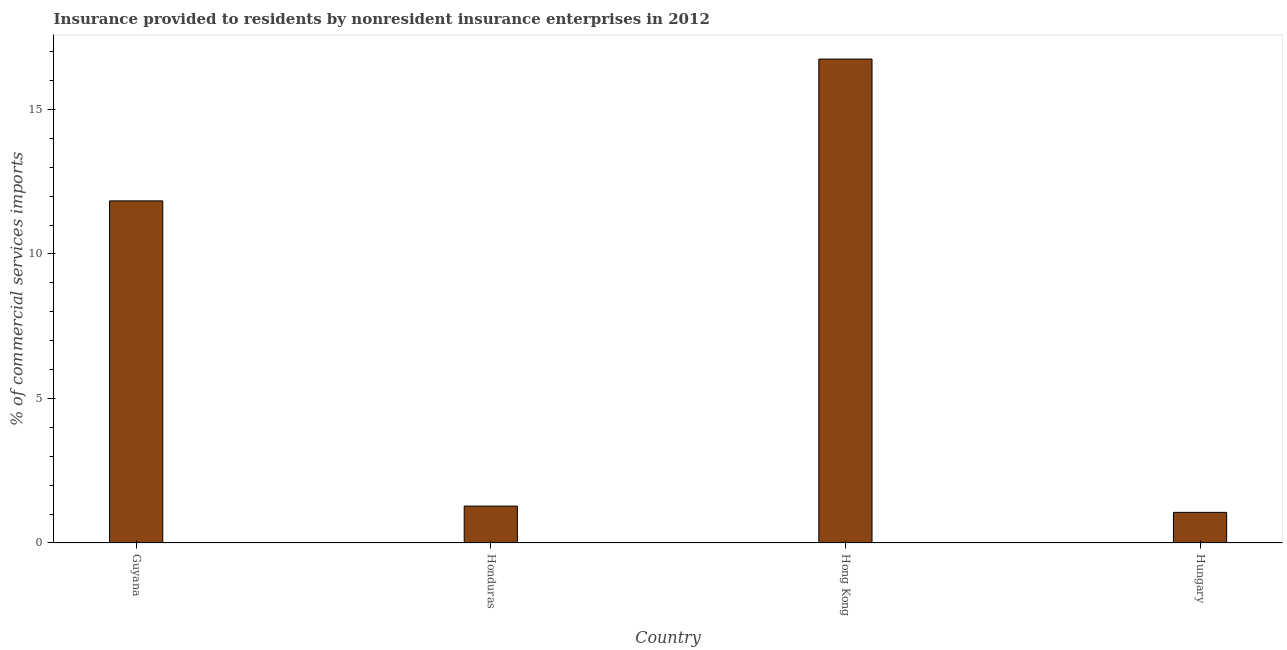Does the graph contain grids?
Keep it short and to the point. No. What is the title of the graph?
Give a very brief answer. Insurance provided to residents by nonresident insurance enterprises in 2012. What is the label or title of the Y-axis?
Keep it short and to the point. % of commercial services imports. What is the insurance provided by non-residents in Hungary?
Make the answer very short. 1.06. Across all countries, what is the maximum insurance provided by non-residents?
Your answer should be compact. 16.74. Across all countries, what is the minimum insurance provided by non-residents?
Your answer should be compact. 1.06. In which country was the insurance provided by non-residents maximum?
Keep it short and to the point. Hong Kong. In which country was the insurance provided by non-residents minimum?
Offer a very short reply. Hungary. What is the sum of the insurance provided by non-residents?
Offer a terse response. 30.91. What is the difference between the insurance provided by non-residents in Guyana and Hungary?
Offer a very short reply. 10.78. What is the average insurance provided by non-residents per country?
Provide a short and direct response. 7.73. What is the median insurance provided by non-residents?
Give a very brief answer. 6.56. In how many countries, is the insurance provided by non-residents greater than 1 %?
Your answer should be very brief. 4. What is the ratio of the insurance provided by non-residents in Guyana to that in Hong Kong?
Keep it short and to the point. 0.71. Is the insurance provided by non-residents in Honduras less than that in Hong Kong?
Give a very brief answer. Yes. What is the difference between the highest and the second highest insurance provided by non-residents?
Provide a succinct answer. 4.91. Is the sum of the insurance provided by non-residents in Honduras and Hungary greater than the maximum insurance provided by non-residents across all countries?
Offer a very short reply. No. What is the difference between the highest and the lowest insurance provided by non-residents?
Keep it short and to the point. 15.68. In how many countries, is the insurance provided by non-residents greater than the average insurance provided by non-residents taken over all countries?
Your answer should be very brief. 2. How many bars are there?
Ensure brevity in your answer.  4. What is the difference between two consecutive major ticks on the Y-axis?
Your response must be concise. 5. What is the % of commercial services imports in Guyana?
Offer a terse response. 11.83. What is the % of commercial services imports of Honduras?
Provide a succinct answer. 1.28. What is the % of commercial services imports in Hong Kong?
Your answer should be compact. 16.74. What is the % of commercial services imports in Hungary?
Provide a short and direct response. 1.06. What is the difference between the % of commercial services imports in Guyana and Honduras?
Provide a short and direct response. 10.56. What is the difference between the % of commercial services imports in Guyana and Hong Kong?
Your response must be concise. -4.91. What is the difference between the % of commercial services imports in Guyana and Hungary?
Your response must be concise. 10.78. What is the difference between the % of commercial services imports in Honduras and Hong Kong?
Offer a very short reply. -15.46. What is the difference between the % of commercial services imports in Honduras and Hungary?
Your answer should be very brief. 0.22. What is the difference between the % of commercial services imports in Hong Kong and Hungary?
Your answer should be very brief. 15.68. What is the ratio of the % of commercial services imports in Guyana to that in Honduras?
Provide a succinct answer. 9.27. What is the ratio of the % of commercial services imports in Guyana to that in Hong Kong?
Offer a terse response. 0.71. What is the ratio of the % of commercial services imports in Guyana to that in Hungary?
Offer a very short reply. 11.17. What is the ratio of the % of commercial services imports in Honduras to that in Hong Kong?
Offer a terse response. 0.08. What is the ratio of the % of commercial services imports in Honduras to that in Hungary?
Make the answer very short. 1.21. What is the ratio of the % of commercial services imports in Hong Kong to that in Hungary?
Keep it short and to the point. 15.8. 